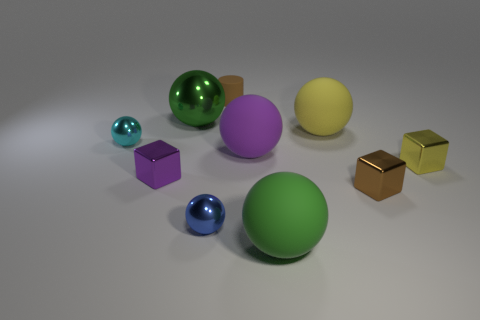Subtract all big metallic spheres. How many spheres are left? 5 Subtract all blue balls. How many balls are left? 5 Subtract 0 cyan cylinders. How many objects are left? 10 Subtract all cylinders. How many objects are left? 9 Subtract 2 spheres. How many spheres are left? 4 Subtract all gray cubes. Subtract all red cylinders. How many cubes are left? 3 Subtract all blue balls. How many blue blocks are left? 0 Subtract all big purple rubber things. Subtract all small brown rubber cylinders. How many objects are left? 8 Add 3 purple matte things. How many purple matte things are left? 4 Add 4 big yellow metallic cubes. How many big yellow metallic cubes exist? 4 